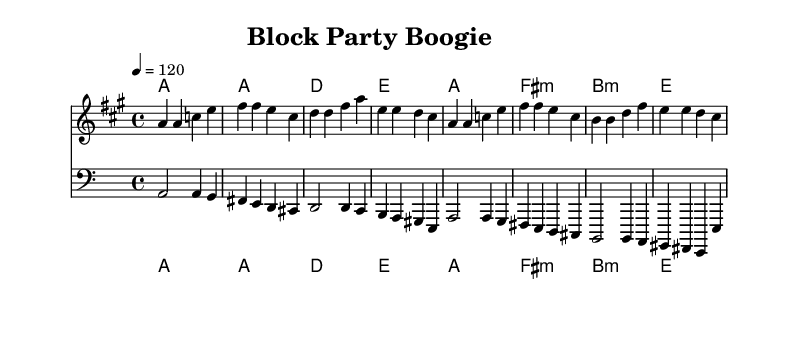What is the key signature of this music? The key signature is A major, which has three sharps: F#, C#, and G#.
Answer: A major What is the time signature of this music? The time signature is indicated at the beginning, showing 4 beats per measure, which is standard for many disco tunes.
Answer: 4/4 What is the tempo marking for the piece? The tempo marking is "4 = 120," which indicates that there are 120 beats per minute, setting a lively disco pace.
Answer: 120 How many measures are in the melody section? By counting the measures in the melody line, there are 8 measures present, which is evident from the bar lines in the music.
Answer: 8 What chord follows the A major chord in the harmony section? The chord progression starts with A major and proceeds to D major, which can be identified from the chord symbols written for each measure.
Answer: D What lyrical theme does this song focus on? The lyrics emphasize community building and connection through a block party, which is reflected in the chorus about uniting neighbors.
Answer: Community Which instrument has the bass clef notation? The bass line is written in the bass clef, which is recognized by the different staff used for the bass part notation.
Answer: Bass 